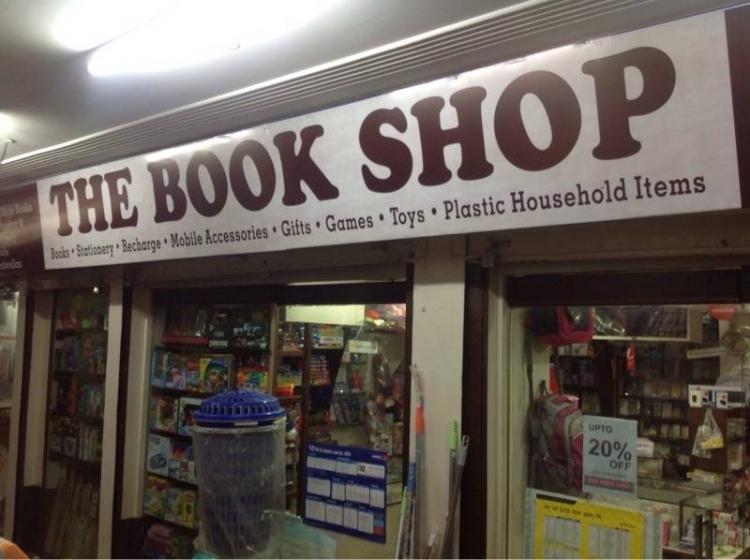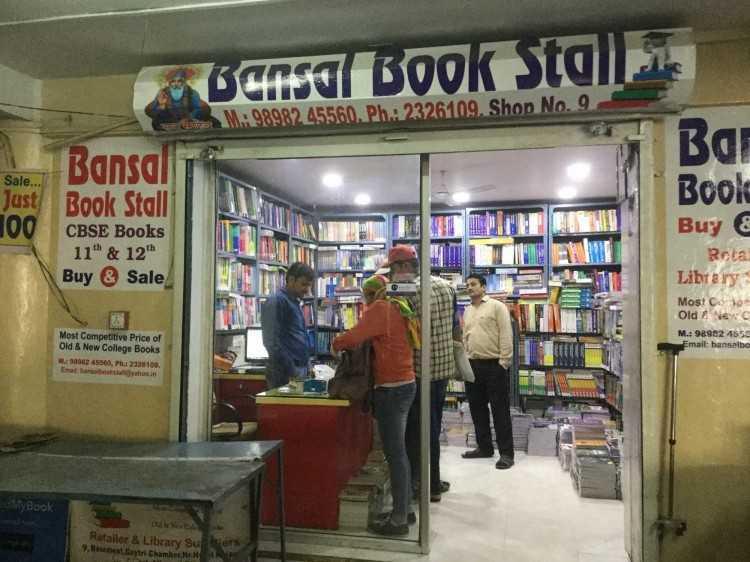The first image is the image on the left, the second image is the image on the right. Assess this claim about the two images: "Each of the images features the outside of a store.". Correct or not? Answer yes or no. Yes. The first image is the image on the left, the second image is the image on the right. For the images shown, is this caption "An image shows one man in a buttoned vest standing in the front area of a book store." true? Answer yes or no. No. 